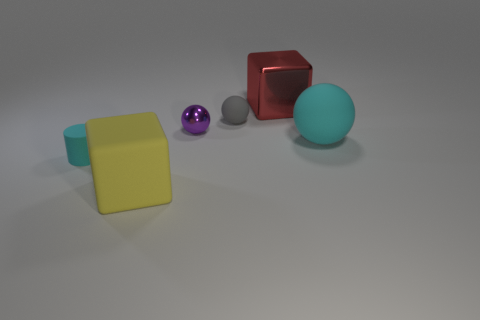Could you infer the potential material of the purple sphere? The small purple sphere appears to have a somewhat reflective surface, suggesting it might be made of a material like polished metal or coated glass, giving it a shiny and reflective appearance. 